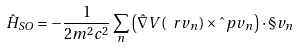Convert formula to latex. <formula><loc_0><loc_0><loc_500><loc_500>\hat { H } _ { S O } = - \frac { 1 } { 2 m ^ { 2 } c ^ { 2 } } \sum _ { n } \left ( \hat { \nabla } V ( \ r v _ { n } ) \times \hat { \ } p v _ { n } \right ) \cdot \S v _ { n }</formula> 